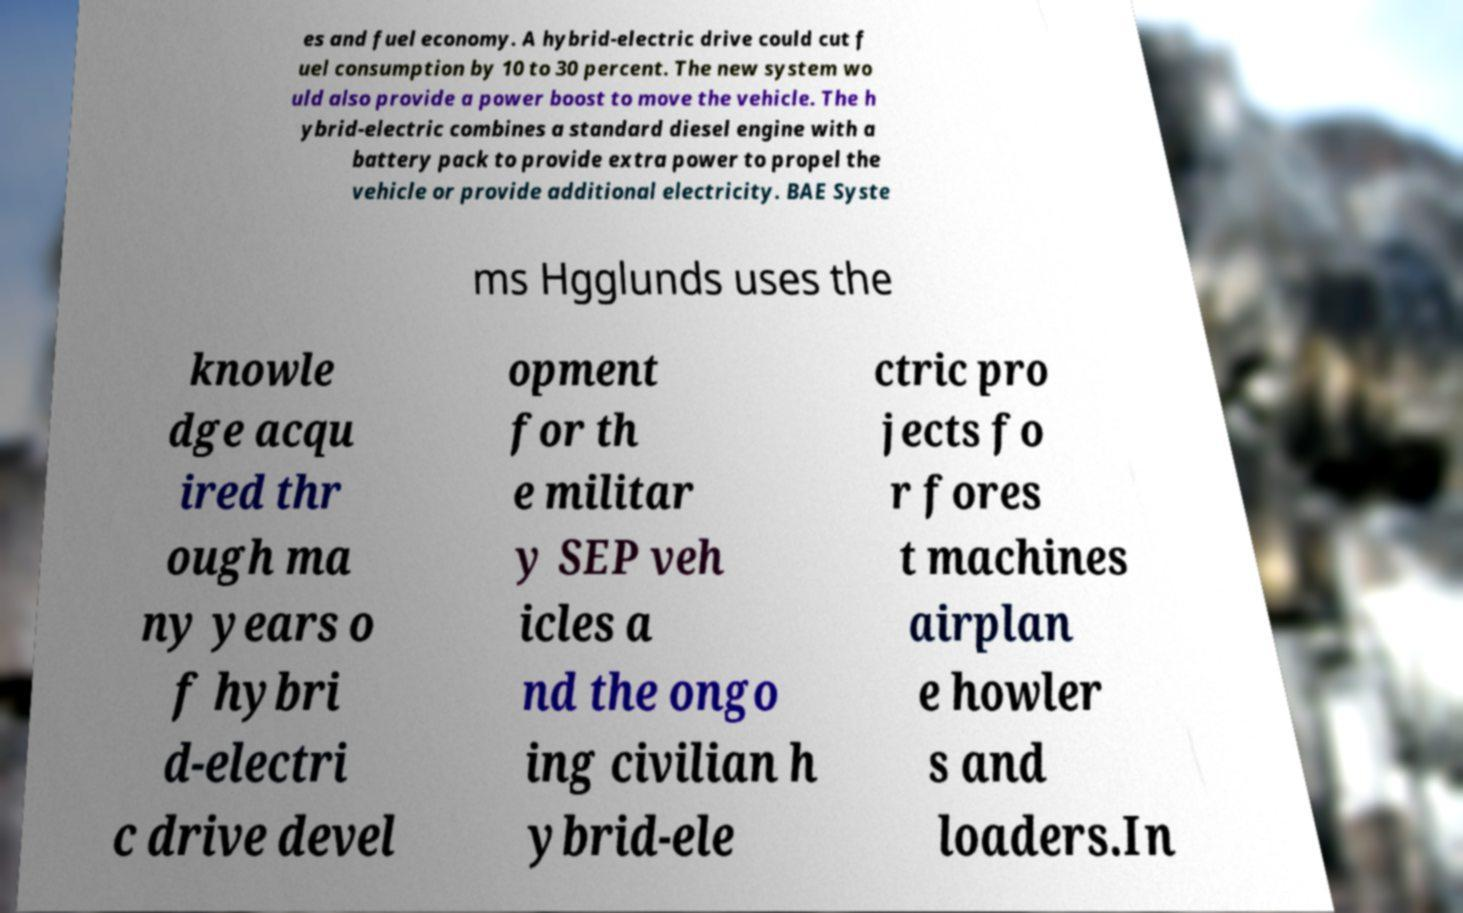Could you assist in decoding the text presented in this image and type it out clearly? es and fuel economy. A hybrid-electric drive could cut f uel consumption by 10 to 30 percent. The new system wo uld also provide a power boost to move the vehicle. The h ybrid-electric combines a standard diesel engine with a battery pack to provide extra power to propel the vehicle or provide additional electricity. BAE Syste ms Hgglunds uses the knowle dge acqu ired thr ough ma ny years o f hybri d-electri c drive devel opment for th e militar y SEP veh icles a nd the ongo ing civilian h ybrid-ele ctric pro jects fo r fores t machines airplan e howler s and loaders.In 